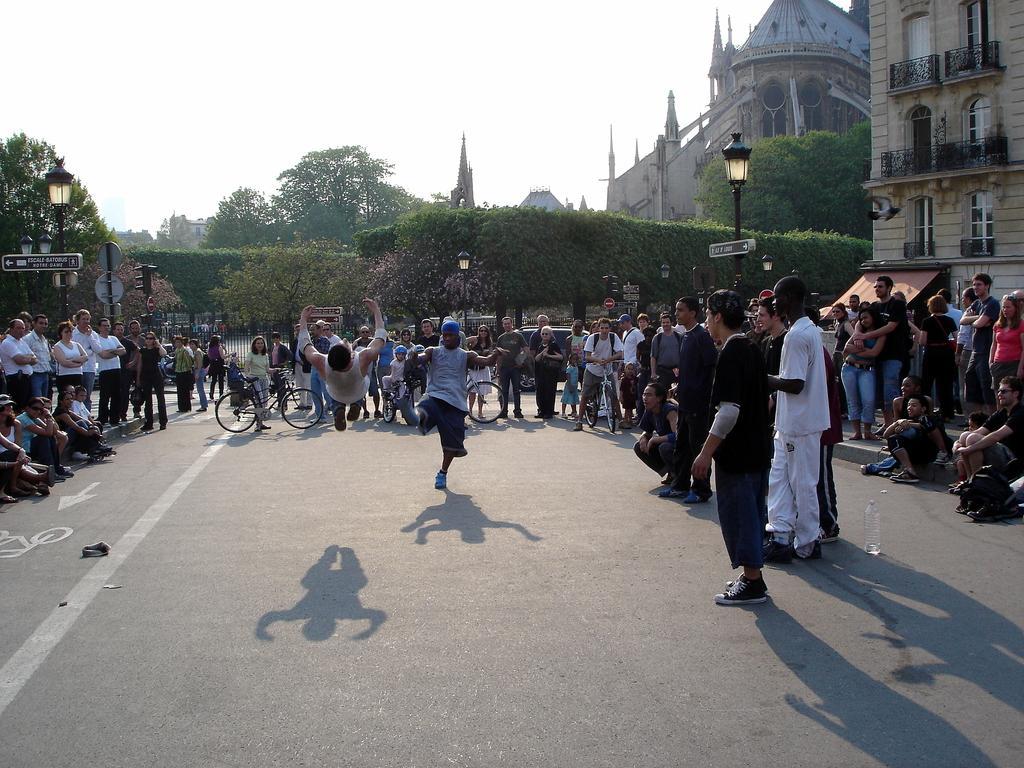Describe this image in one or two sentences. In this picture there is a person in air and there is another person raised one of his leg beside him and there are few people around them and there are few buildings and trees in the background. 